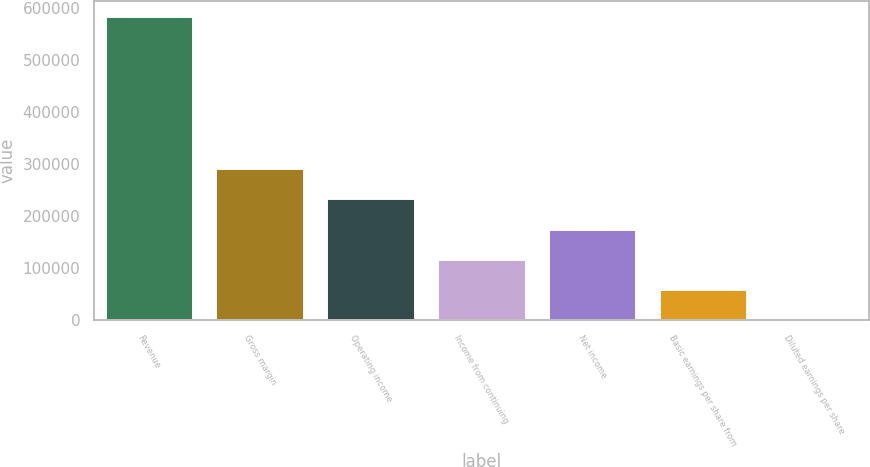Convert chart to OTSL. <chart><loc_0><loc_0><loc_500><loc_500><bar_chart><fcel>Revenue<fcel>Gross margin<fcel>Operating income<fcel>Income from continuing<fcel>Net income<fcel>Basic earnings per share from<fcel>Diluted earnings per share<nl><fcel>584681<fcel>292341<fcel>233873<fcel>116936<fcel>175404<fcel>58468.3<fcel>0.26<nl></chart> 